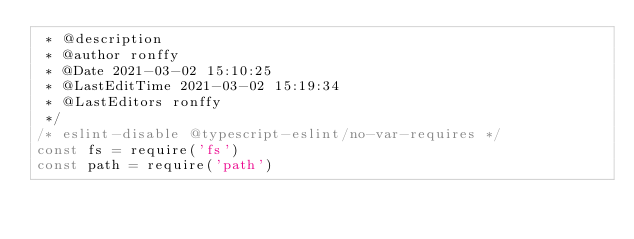Convert code to text. <code><loc_0><loc_0><loc_500><loc_500><_JavaScript_> * @description 
 * @author ronffy
 * @Date 2021-03-02 15:10:25
 * @LastEditTime 2021-03-02 15:19:34
 * @LastEditors ronffy
 */
/* eslint-disable @typescript-eslint/no-var-requires */
const fs = require('fs')
const path = require('path')</code> 